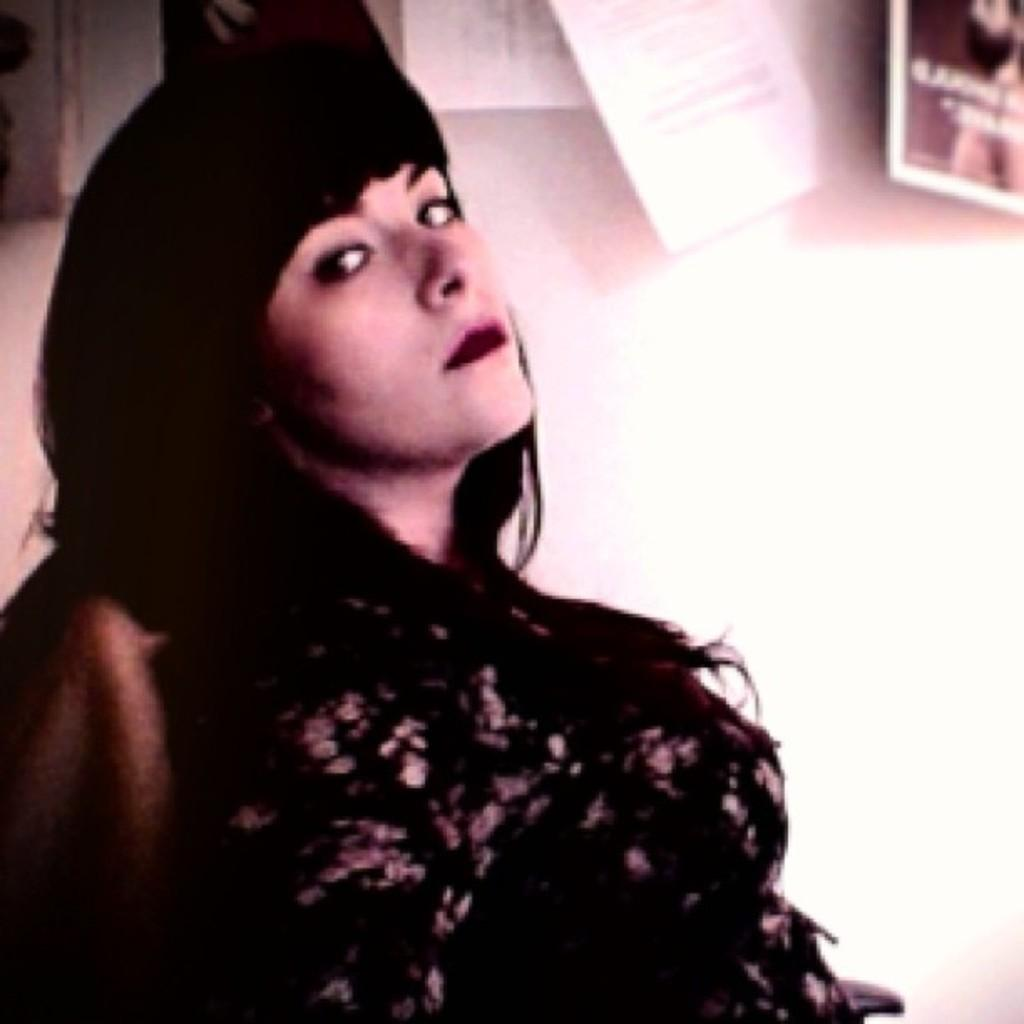What is the color of the wall in the image? There is a white color wall in the image. What objects can be seen on the wall in the image? Papers are visible on the wall in the image. Who is present in the image? There is a woman in the image. What is the woman wearing? The woman is wearing a black color dress. What is the woman doing in the image? The woman is sitting on a sofa. Can you see any cherries on the list in the image? There is no list or cherries present in the image. 